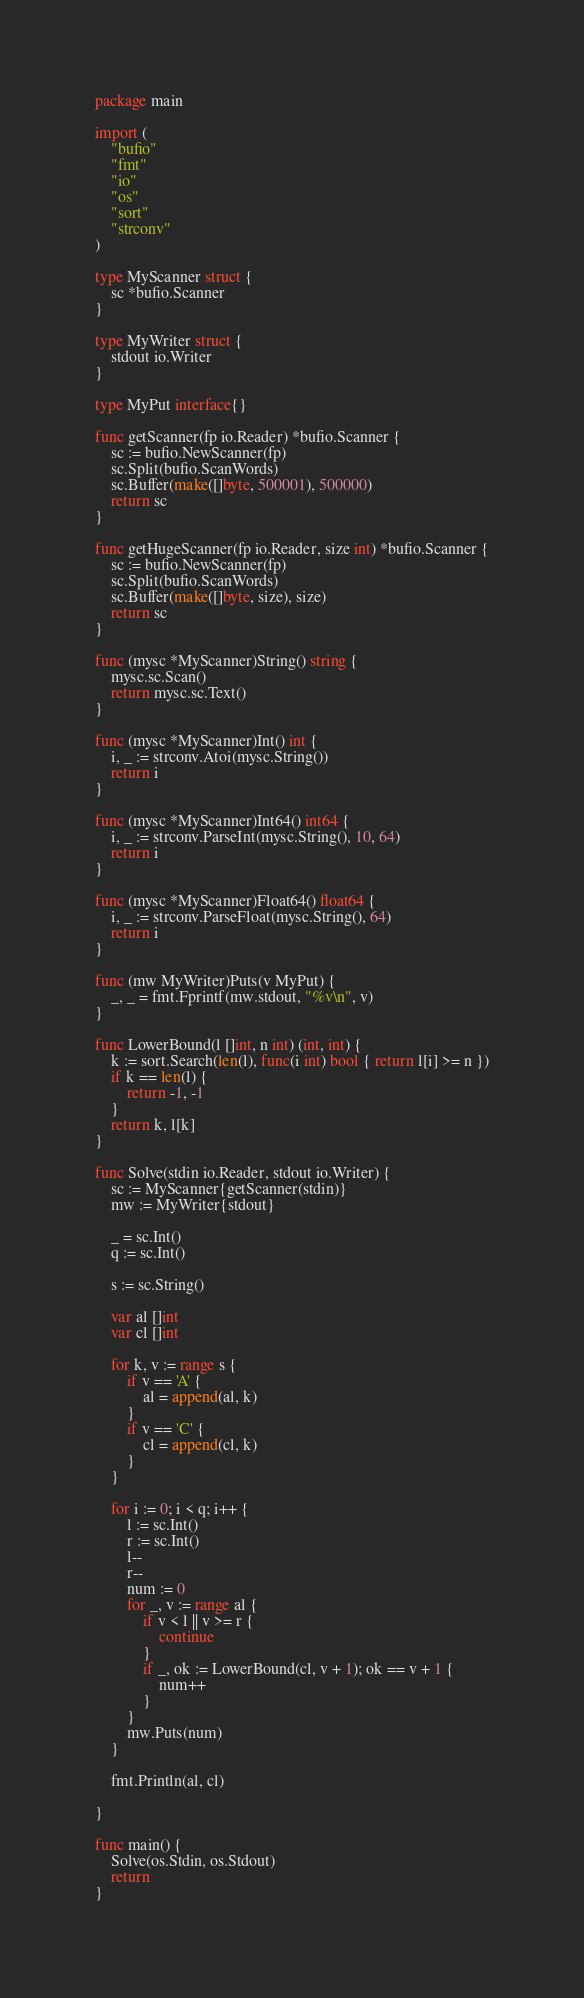Convert code to text. <code><loc_0><loc_0><loc_500><loc_500><_Go_>package main

import (
	"bufio"
	"fmt"
	"io"
	"os"
	"sort"
	"strconv"
)

type MyScanner struct {
	sc *bufio.Scanner
}

type MyWriter struct {
	stdout io.Writer
}

type MyPut interface{}

func getScanner(fp io.Reader) *bufio.Scanner {
	sc := bufio.NewScanner(fp)
	sc.Split(bufio.ScanWords)
	sc.Buffer(make([]byte, 500001), 500000)
	return sc
}

func getHugeScanner(fp io.Reader, size int) *bufio.Scanner {
	sc := bufio.NewScanner(fp)
	sc.Split(bufio.ScanWords)
	sc.Buffer(make([]byte, size), size)
	return sc
}

func (mysc *MyScanner)String() string {
	mysc.sc.Scan()
	return mysc.sc.Text()
}

func (mysc *MyScanner)Int() int {
	i, _ := strconv.Atoi(mysc.String())
	return i
}

func (mysc *MyScanner)Int64() int64 {
	i, _ := strconv.ParseInt(mysc.String(), 10, 64)
	return i
}

func (mysc *MyScanner)Float64() float64 {
	i, _ := strconv.ParseFloat(mysc.String(), 64)
	return i
}

func (mw MyWriter)Puts(v MyPut) {
	_, _ = fmt.Fprintf(mw.stdout, "%v\n", v)
}

func LowerBound(l []int, n int) (int, int) {
	k := sort.Search(len(l), func(i int) bool { return l[i] >= n })
	if k == len(l) {
		return -1, -1
	}
	return k, l[k]
}

func Solve(stdin io.Reader, stdout io.Writer) {
	sc := MyScanner{getScanner(stdin)}
	mw := MyWriter{stdout}

	_ = sc.Int()
	q := sc.Int()

	s := sc.String()

	var al []int
	var cl []int

	for k, v := range s {
		if v == 'A' {
			al = append(al, k)
		}
		if v == 'C' {
			cl = append(cl, k)
		}
	}

	for i := 0; i < q; i++ {
		l := sc.Int()
		r := sc.Int()
		l--
		r--
		num := 0
		for _, v := range al {
			if v < l || v >= r {
				continue
			}
			if _, ok := LowerBound(cl, v + 1); ok == v + 1 {
				num++
			}
		}
		mw.Puts(num)
	}

	fmt.Println(al, cl)

}

func main() {
	Solve(os.Stdin, os.Stdout)
	return
}</code> 